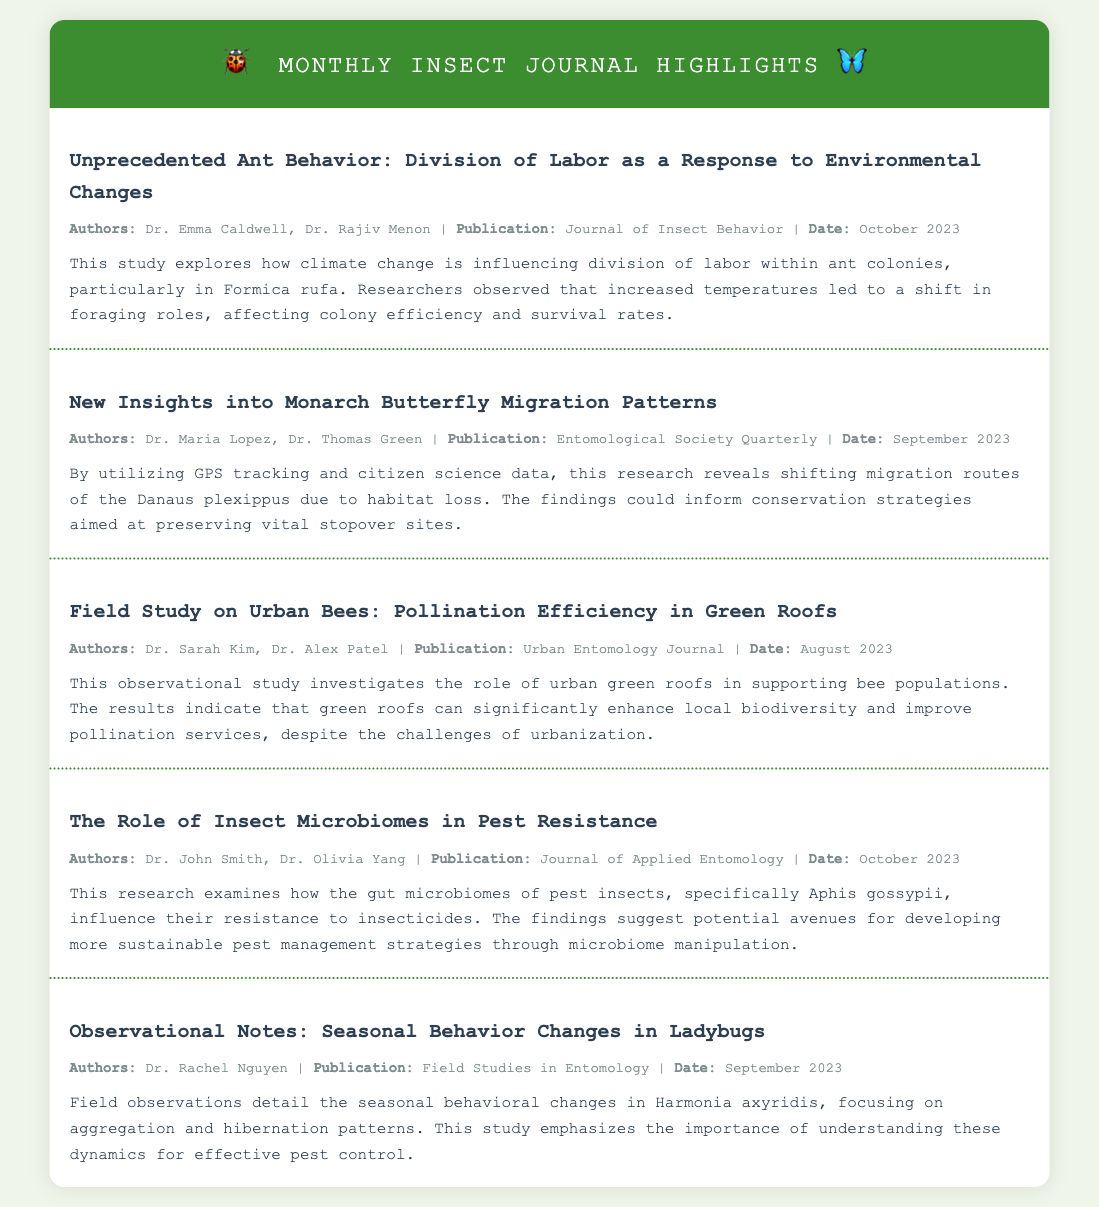What is the title of the first journal entry? The title is found at the beginning of the first journal entry, highlighting the researchers' focus on ant behavior.
Answer: Unprecedented Ant Behavior: Division of Labor as a Response to Environmental Changes Who are the authors of the study about monarch butterflies? The authors are listed in the metadata section of the relevant journal entry.
Answer: Dr. Maria Lopez, Dr. Thomas Green What publication features the research on urban bees? The publication is specified in the metadata of the journal entry regarding urban bees and green roofs.
Answer: Urban Entomology Journal What is the primary focus of the paper on the role of insect microbiomes? The main focus can be found in the summary, describing the relationship between microbiomes and pest resistance.
Answer: Pest resistance When was the observational study on ladybugs published? This date is mentioned in the metadata section of the journal entry dedicated to ladybugs.
Answer: September 2023 Who conducted the study on the seasonal behavior changes in ladybugs? The authors are identified in the metadata of the respective journal entry.
Answer: Dr. Rachel Nguyen What research methods were used in the monarch butterfly migration study? The methods include GPS tracking and citizen science data, as described in the summary.
Answer: GPS tracking and citizen science data How does the article on urban bees assess their effectiveness? The effectiveness is evaluated based on the observed enhancements in local biodiversity and pollination services.
Answer: Pollination efficiency in green roofs 